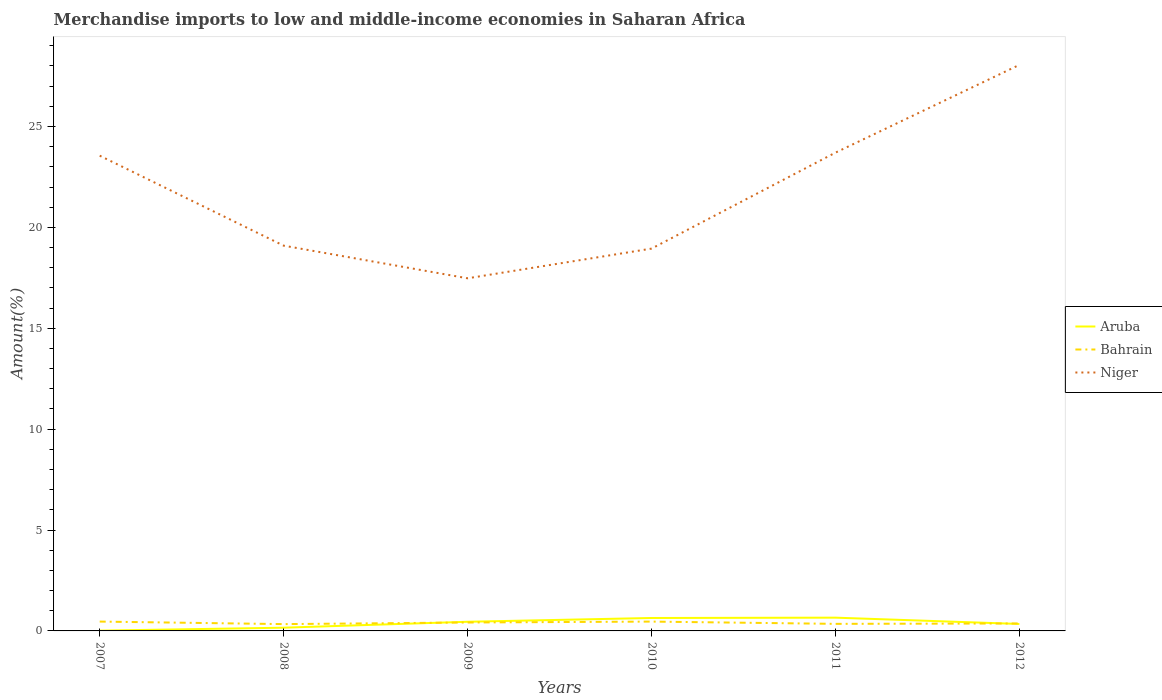Does the line corresponding to Niger intersect with the line corresponding to Bahrain?
Give a very brief answer. No. Is the number of lines equal to the number of legend labels?
Make the answer very short. Yes. Across all years, what is the maximum percentage of amount earned from merchandise imports in Aruba?
Give a very brief answer. 0.01. What is the total percentage of amount earned from merchandise imports in Niger in the graph?
Offer a terse response. -4.76. What is the difference between the highest and the second highest percentage of amount earned from merchandise imports in Niger?
Your response must be concise. 10.58. What is the difference between the highest and the lowest percentage of amount earned from merchandise imports in Aruba?
Make the answer very short. 3. How many years are there in the graph?
Keep it short and to the point. 6. What is the difference between two consecutive major ticks on the Y-axis?
Ensure brevity in your answer.  5. Does the graph contain any zero values?
Provide a short and direct response. No. Where does the legend appear in the graph?
Give a very brief answer. Center right. How are the legend labels stacked?
Your answer should be very brief. Vertical. What is the title of the graph?
Give a very brief answer. Merchandise imports to low and middle-income economies in Saharan Africa. What is the label or title of the X-axis?
Provide a succinct answer. Years. What is the label or title of the Y-axis?
Provide a succinct answer. Amount(%). What is the Amount(%) in Aruba in 2007?
Make the answer very short. 0.01. What is the Amount(%) of Bahrain in 2007?
Ensure brevity in your answer.  0.46. What is the Amount(%) in Niger in 2007?
Your response must be concise. 23.55. What is the Amount(%) of Aruba in 2008?
Ensure brevity in your answer.  0.16. What is the Amount(%) in Bahrain in 2008?
Provide a short and direct response. 0.34. What is the Amount(%) of Niger in 2008?
Keep it short and to the point. 19.09. What is the Amount(%) of Aruba in 2009?
Your response must be concise. 0.45. What is the Amount(%) in Bahrain in 2009?
Offer a terse response. 0.42. What is the Amount(%) of Niger in 2009?
Your answer should be very brief. 17.48. What is the Amount(%) in Aruba in 2010?
Your answer should be very brief. 0.64. What is the Amount(%) in Bahrain in 2010?
Your answer should be very brief. 0.46. What is the Amount(%) of Niger in 2010?
Provide a succinct answer. 18.95. What is the Amount(%) in Aruba in 2011?
Your answer should be very brief. 0.66. What is the Amount(%) of Bahrain in 2011?
Offer a very short reply. 0.35. What is the Amount(%) of Niger in 2011?
Offer a terse response. 23.7. What is the Amount(%) of Aruba in 2012?
Keep it short and to the point. 0.34. What is the Amount(%) in Bahrain in 2012?
Provide a succinct answer. 0.37. What is the Amount(%) of Niger in 2012?
Ensure brevity in your answer.  28.05. Across all years, what is the maximum Amount(%) of Aruba?
Offer a very short reply. 0.66. Across all years, what is the maximum Amount(%) in Bahrain?
Provide a succinct answer. 0.46. Across all years, what is the maximum Amount(%) of Niger?
Provide a short and direct response. 28.05. Across all years, what is the minimum Amount(%) in Aruba?
Ensure brevity in your answer.  0.01. Across all years, what is the minimum Amount(%) of Bahrain?
Your answer should be compact. 0.34. Across all years, what is the minimum Amount(%) of Niger?
Ensure brevity in your answer.  17.48. What is the total Amount(%) in Aruba in the graph?
Provide a succinct answer. 2.27. What is the total Amount(%) in Bahrain in the graph?
Keep it short and to the point. 2.4. What is the total Amount(%) in Niger in the graph?
Provide a short and direct response. 130.83. What is the difference between the Amount(%) of Aruba in 2007 and that in 2008?
Provide a succinct answer. -0.15. What is the difference between the Amount(%) in Bahrain in 2007 and that in 2008?
Provide a short and direct response. 0.13. What is the difference between the Amount(%) of Niger in 2007 and that in 2008?
Ensure brevity in your answer.  4.46. What is the difference between the Amount(%) of Aruba in 2007 and that in 2009?
Provide a succinct answer. -0.44. What is the difference between the Amount(%) in Bahrain in 2007 and that in 2009?
Offer a terse response. 0.05. What is the difference between the Amount(%) in Niger in 2007 and that in 2009?
Offer a very short reply. 6.08. What is the difference between the Amount(%) of Aruba in 2007 and that in 2010?
Provide a succinct answer. -0.63. What is the difference between the Amount(%) in Bahrain in 2007 and that in 2010?
Ensure brevity in your answer.  0. What is the difference between the Amount(%) of Niger in 2007 and that in 2010?
Offer a terse response. 4.61. What is the difference between the Amount(%) of Aruba in 2007 and that in 2011?
Make the answer very short. -0.64. What is the difference between the Amount(%) of Bahrain in 2007 and that in 2011?
Give a very brief answer. 0.11. What is the difference between the Amount(%) in Niger in 2007 and that in 2011?
Ensure brevity in your answer.  -0.15. What is the difference between the Amount(%) in Aruba in 2007 and that in 2012?
Provide a succinct answer. -0.33. What is the difference between the Amount(%) of Bahrain in 2007 and that in 2012?
Your answer should be compact. 0.09. What is the difference between the Amount(%) in Niger in 2007 and that in 2012?
Keep it short and to the point. -4.5. What is the difference between the Amount(%) of Aruba in 2008 and that in 2009?
Make the answer very short. -0.29. What is the difference between the Amount(%) of Bahrain in 2008 and that in 2009?
Your answer should be compact. -0.08. What is the difference between the Amount(%) of Niger in 2008 and that in 2009?
Ensure brevity in your answer.  1.62. What is the difference between the Amount(%) of Aruba in 2008 and that in 2010?
Offer a very short reply. -0.48. What is the difference between the Amount(%) of Bahrain in 2008 and that in 2010?
Keep it short and to the point. -0.12. What is the difference between the Amount(%) of Niger in 2008 and that in 2010?
Offer a terse response. 0.15. What is the difference between the Amount(%) in Aruba in 2008 and that in 2011?
Your answer should be compact. -0.5. What is the difference between the Amount(%) of Bahrain in 2008 and that in 2011?
Keep it short and to the point. -0.01. What is the difference between the Amount(%) in Niger in 2008 and that in 2011?
Your response must be concise. -4.61. What is the difference between the Amount(%) in Aruba in 2008 and that in 2012?
Give a very brief answer. -0.18. What is the difference between the Amount(%) in Bahrain in 2008 and that in 2012?
Ensure brevity in your answer.  -0.03. What is the difference between the Amount(%) of Niger in 2008 and that in 2012?
Your answer should be compact. -8.96. What is the difference between the Amount(%) in Aruba in 2009 and that in 2010?
Your response must be concise. -0.19. What is the difference between the Amount(%) in Bahrain in 2009 and that in 2010?
Your answer should be very brief. -0.05. What is the difference between the Amount(%) of Niger in 2009 and that in 2010?
Offer a terse response. -1.47. What is the difference between the Amount(%) in Aruba in 2009 and that in 2011?
Offer a terse response. -0.2. What is the difference between the Amount(%) of Bahrain in 2009 and that in 2011?
Provide a succinct answer. 0.07. What is the difference between the Amount(%) in Niger in 2009 and that in 2011?
Ensure brevity in your answer.  -6.23. What is the difference between the Amount(%) of Aruba in 2009 and that in 2012?
Your answer should be very brief. 0.11. What is the difference between the Amount(%) in Bahrain in 2009 and that in 2012?
Make the answer very short. 0.05. What is the difference between the Amount(%) in Niger in 2009 and that in 2012?
Provide a short and direct response. -10.58. What is the difference between the Amount(%) of Aruba in 2010 and that in 2011?
Your response must be concise. -0.02. What is the difference between the Amount(%) of Bahrain in 2010 and that in 2011?
Your answer should be very brief. 0.11. What is the difference between the Amount(%) in Niger in 2010 and that in 2011?
Your response must be concise. -4.76. What is the difference between the Amount(%) in Aruba in 2010 and that in 2012?
Give a very brief answer. 0.3. What is the difference between the Amount(%) in Bahrain in 2010 and that in 2012?
Give a very brief answer. 0.09. What is the difference between the Amount(%) in Niger in 2010 and that in 2012?
Your answer should be very brief. -9.11. What is the difference between the Amount(%) in Aruba in 2011 and that in 2012?
Provide a succinct answer. 0.31. What is the difference between the Amount(%) in Bahrain in 2011 and that in 2012?
Your response must be concise. -0.02. What is the difference between the Amount(%) in Niger in 2011 and that in 2012?
Give a very brief answer. -4.35. What is the difference between the Amount(%) in Aruba in 2007 and the Amount(%) in Bahrain in 2008?
Keep it short and to the point. -0.32. What is the difference between the Amount(%) in Aruba in 2007 and the Amount(%) in Niger in 2008?
Provide a short and direct response. -19.08. What is the difference between the Amount(%) of Bahrain in 2007 and the Amount(%) of Niger in 2008?
Provide a short and direct response. -18.63. What is the difference between the Amount(%) in Aruba in 2007 and the Amount(%) in Bahrain in 2009?
Give a very brief answer. -0.4. What is the difference between the Amount(%) of Aruba in 2007 and the Amount(%) of Niger in 2009?
Your answer should be compact. -17.46. What is the difference between the Amount(%) in Bahrain in 2007 and the Amount(%) in Niger in 2009?
Provide a succinct answer. -17.01. What is the difference between the Amount(%) in Aruba in 2007 and the Amount(%) in Bahrain in 2010?
Keep it short and to the point. -0.45. What is the difference between the Amount(%) of Aruba in 2007 and the Amount(%) of Niger in 2010?
Provide a short and direct response. -18.93. What is the difference between the Amount(%) in Bahrain in 2007 and the Amount(%) in Niger in 2010?
Your answer should be compact. -18.48. What is the difference between the Amount(%) of Aruba in 2007 and the Amount(%) of Bahrain in 2011?
Give a very brief answer. -0.34. What is the difference between the Amount(%) of Aruba in 2007 and the Amount(%) of Niger in 2011?
Give a very brief answer. -23.69. What is the difference between the Amount(%) of Bahrain in 2007 and the Amount(%) of Niger in 2011?
Your answer should be very brief. -23.24. What is the difference between the Amount(%) of Aruba in 2007 and the Amount(%) of Bahrain in 2012?
Offer a terse response. -0.36. What is the difference between the Amount(%) of Aruba in 2007 and the Amount(%) of Niger in 2012?
Make the answer very short. -28.04. What is the difference between the Amount(%) in Bahrain in 2007 and the Amount(%) in Niger in 2012?
Your answer should be very brief. -27.59. What is the difference between the Amount(%) of Aruba in 2008 and the Amount(%) of Bahrain in 2009?
Offer a very short reply. -0.26. What is the difference between the Amount(%) of Aruba in 2008 and the Amount(%) of Niger in 2009?
Your answer should be very brief. -17.32. What is the difference between the Amount(%) in Bahrain in 2008 and the Amount(%) in Niger in 2009?
Your answer should be very brief. -17.14. What is the difference between the Amount(%) of Aruba in 2008 and the Amount(%) of Bahrain in 2010?
Offer a terse response. -0.3. What is the difference between the Amount(%) of Aruba in 2008 and the Amount(%) of Niger in 2010?
Provide a succinct answer. -18.79. What is the difference between the Amount(%) in Bahrain in 2008 and the Amount(%) in Niger in 2010?
Your answer should be compact. -18.61. What is the difference between the Amount(%) of Aruba in 2008 and the Amount(%) of Bahrain in 2011?
Provide a short and direct response. -0.19. What is the difference between the Amount(%) of Aruba in 2008 and the Amount(%) of Niger in 2011?
Make the answer very short. -23.54. What is the difference between the Amount(%) of Bahrain in 2008 and the Amount(%) of Niger in 2011?
Make the answer very short. -23.37. What is the difference between the Amount(%) in Aruba in 2008 and the Amount(%) in Bahrain in 2012?
Your answer should be very brief. -0.21. What is the difference between the Amount(%) of Aruba in 2008 and the Amount(%) of Niger in 2012?
Offer a very short reply. -27.89. What is the difference between the Amount(%) in Bahrain in 2008 and the Amount(%) in Niger in 2012?
Your answer should be compact. -27.72. What is the difference between the Amount(%) of Aruba in 2009 and the Amount(%) of Bahrain in 2010?
Offer a terse response. -0.01. What is the difference between the Amount(%) of Aruba in 2009 and the Amount(%) of Niger in 2010?
Give a very brief answer. -18.49. What is the difference between the Amount(%) of Bahrain in 2009 and the Amount(%) of Niger in 2010?
Ensure brevity in your answer.  -18.53. What is the difference between the Amount(%) in Aruba in 2009 and the Amount(%) in Bahrain in 2011?
Your answer should be very brief. 0.1. What is the difference between the Amount(%) in Aruba in 2009 and the Amount(%) in Niger in 2011?
Give a very brief answer. -23.25. What is the difference between the Amount(%) of Bahrain in 2009 and the Amount(%) of Niger in 2011?
Make the answer very short. -23.29. What is the difference between the Amount(%) in Aruba in 2009 and the Amount(%) in Bahrain in 2012?
Provide a succinct answer. 0.08. What is the difference between the Amount(%) of Aruba in 2009 and the Amount(%) of Niger in 2012?
Provide a short and direct response. -27.6. What is the difference between the Amount(%) of Bahrain in 2009 and the Amount(%) of Niger in 2012?
Give a very brief answer. -27.64. What is the difference between the Amount(%) in Aruba in 2010 and the Amount(%) in Bahrain in 2011?
Ensure brevity in your answer.  0.29. What is the difference between the Amount(%) of Aruba in 2010 and the Amount(%) of Niger in 2011?
Provide a succinct answer. -23.06. What is the difference between the Amount(%) of Bahrain in 2010 and the Amount(%) of Niger in 2011?
Make the answer very short. -23.24. What is the difference between the Amount(%) in Aruba in 2010 and the Amount(%) in Bahrain in 2012?
Offer a very short reply. 0.27. What is the difference between the Amount(%) in Aruba in 2010 and the Amount(%) in Niger in 2012?
Your answer should be compact. -27.41. What is the difference between the Amount(%) in Bahrain in 2010 and the Amount(%) in Niger in 2012?
Offer a very short reply. -27.59. What is the difference between the Amount(%) in Aruba in 2011 and the Amount(%) in Bahrain in 2012?
Provide a short and direct response. 0.29. What is the difference between the Amount(%) in Aruba in 2011 and the Amount(%) in Niger in 2012?
Provide a succinct answer. -27.4. What is the difference between the Amount(%) in Bahrain in 2011 and the Amount(%) in Niger in 2012?
Your answer should be compact. -27.7. What is the average Amount(%) of Aruba per year?
Offer a terse response. 0.38. What is the average Amount(%) in Bahrain per year?
Your response must be concise. 0.4. What is the average Amount(%) of Niger per year?
Offer a very short reply. 21.8. In the year 2007, what is the difference between the Amount(%) in Aruba and Amount(%) in Bahrain?
Offer a very short reply. -0.45. In the year 2007, what is the difference between the Amount(%) in Aruba and Amount(%) in Niger?
Offer a very short reply. -23.54. In the year 2007, what is the difference between the Amount(%) of Bahrain and Amount(%) of Niger?
Ensure brevity in your answer.  -23.09. In the year 2008, what is the difference between the Amount(%) of Aruba and Amount(%) of Bahrain?
Provide a succinct answer. -0.18. In the year 2008, what is the difference between the Amount(%) in Aruba and Amount(%) in Niger?
Offer a very short reply. -18.93. In the year 2008, what is the difference between the Amount(%) of Bahrain and Amount(%) of Niger?
Give a very brief answer. -18.76. In the year 2009, what is the difference between the Amount(%) of Aruba and Amount(%) of Bahrain?
Offer a terse response. 0.04. In the year 2009, what is the difference between the Amount(%) of Aruba and Amount(%) of Niger?
Your response must be concise. -17.02. In the year 2009, what is the difference between the Amount(%) of Bahrain and Amount(%) of Niger?
Give a very brief answer. -17.06. In the year 2010, what is the difference between the Amount(%) in Aruba and Amount(%) in Bahrain?
Offer a terse response. 0.18. In the year 2010, what is the difference between the Amount(%) in Aruba and Amount(%) in Niger?
Your response must be concise. -18.31. In the year 2010, what is the difference between the Amount(%) in Bahrain and Amount(%) in Niger?
Your answer should be compact. -18.49. In the year 2011, what is the difference between the Amount(%) in Aruba and Amount(%) in Bahrain?
Ensure brevity in your answer.  0.31. In the year 2011, what is the difference between the Amount(%) of Aruba and Amount(%) of Niger?
Offer a very short reply. -23.05. In the year 2011, what is the difference between the Amount(%) of Bahrain and Amount(%) of Niger?
Offer a terse response. -23.35. In the year 2012, what is the difference between the Amount(%) of Aruba and Amount(%) of Bahrain?
Keep it short and to the point. -0.02. In the year 2012, what is the difference between the Amount(%) in Aruba and Amount(%) in Niger?
Your answer should be compact. -27.71. In the year 2012, what is the difference between the Amount(%) of Bahrain and Amount(%) of Niger?
Give a very brief answer. -27.68. What is the ratio of the Amount(%) of Aruba in 2007 to that in 2008?
Make the answer very short. 0.09. What is the ratio of the Amount(%) of Bahrain in 2007 to that in 2008?
Your answer should be compact. 1.37. What is the ratio of the Amount(%) of Niger in 2007 to that in 2008?
Ensure brevity in your answer.  1.23. What is the ratio of the Amount(%) of Aruba in 2007 to that in 2009?
Make the answer very short. 0.03. What is the ratio of the Amount(%) of Bahrain in 2007 to that in 2009?
Provide a short and direct response. 1.11. What is the ratio of the Amount(%) in Niger in 2007 to that in 2009?
Offer a terse response. 1.35. What is the ratio of the Amount(%) in Aruba in 2007 to that in 2010?
Your response must be concise. 0.02. What is the ratio of the Amount(%) of Bahrain in 2007 to that in 2010?
Your response must be concise. 1. What is the ratio of the Amount(%) of Niger in 2007 to that in 2010?
Offer a terse response. 1.24. What is the ratio of the Amount(%) of Aruba in 2007 to that in 2011?
Keep it short and to the point. 0.02. What is the ratio of the Amount(%) in Bahrain in 2007 to that in 2011?
Provide a short and direct response. 1.32. What is the ratio of the Amount(%) in Niger in 2007 to that in 2011?
Make the answer very short. 0.99. What is the ratio of the Amount(%) in Aruba in 2007 to that in 2012?
Your response must be concise. 0.04. What is the ratio of the Amount(%) of Bahrain in 2007 to that in 2012?
Make the answer very short. 1.25. What is the ratio of the Amount(%) in Niger in 2007 to that in 2012?
Give a very brief answer. 0.84. What is the ratio of the Amount(%) of Aruba in 2008 to that in 2009?
Offer a terse response. 0.35. What is the ratio of the Amount(%) in Bahrain in 2008 to that in 2009?
Give a very brief answer. 0.81. What is the ratio of the Amount(%) of Niger in 2008 to that in 2009?
Keep it short and to the point. 1.09. What is the ratio of the Amount(%) of Aruba in 2008 to that in 2010?
Your answer should be very brief. 0.25. What is the ratio of the Amount(%) in Bahrain in 2008 to that in 2010?
Offer a very short reply. 0.73. What is the ratio of the Amount(%) in Niger in 2008 to that in 2010?
Make the answer very short. 1.01. What is the ratio of the Amount(%) in Aruba in 2008 to that in 2011?
Offer a terse response. 0.24. What is the ratio of the Amount(%) in Bahrain in 2008 to that in 2011?
Ensure brevity in your answer.  0.96. What is the ratio of the Amount(%) of Niger in 2008 to that in 2011?
Keep it short and to the point. 0.81. What is the ratio of the Amount(%) in Aruba in 2008 to that in 2012?
Your response must be concise. 0.46. What is the ratio of the Amount(%) in Bahrain in 2008 to that in 2012?
Give a very brief answer. 0.91. What is the ratio of the Amount(%) of Niger in 2008 to that in 2012?
Ensure brevity in your answer.  0.68. What is the ratio of the Amount(%) of Aruba in 2009 to that in 2010?
Give a very brief answer. 0.71. What is the ratio of the Amount(%) of Bahrain in 2009 to that in 2010?
Your response must be concise. 0.9. What is the ratio of the Amount(%) of Niger in 2009 to that in 2010?
Keep it short and to the point. 0.92. What is the ratio of the Amount(%) in Aruba in 2009 to that in 2011?
Your answer should be compact. 0.69. What is the ratio of the Amount(%) in Bahrain in 2009 to that in 2011?
Provide a short and direct response. 1.19. What is the ratio of the Amount(%) of Niger in 2009 to that in 2011?
Ensure brevity in your answer.  0.74. What is the ratio of the Amount(%) of Aruba in 2009 to that in 2012?
Make the answer very short. 1.32. What is the ratio of the Amount(%) in Bahrain in 2009 to that in 2012?
Provide a succinct answer. 1.13. What is the ratio of the Amount(%) of Niger in 2009 to that in 2012?
Make the answer very short. 0.62. What is the ratio of the Amount(%) of Aruba in 2010 to that in 2011?
Ensure brevity in your answer.  0.98. What is the ratio of the Amount(%) in Bahrain in 2010 to that in 2011?
Provide a succinct answer. 1.32. What is the ratio of the Amount(%) in Niger in 2010 to that in 2011?
Provide a succinct answer. 0.8. What is the ratio of the Amount(%) in Aruba in 2010 to that in 2012?
Your answer should be compact. 1.86. What is the ratio of the Amount(%) in Bahrain in 2010 to that in 2012?
Offer a very short reply. 1.25. What is the ratio of the Amount(%) in Niger in 2010 to that in 2012?
Ensure brevity in your answer.  0.68. What is the ratio of the Amount(%) of Aruba in 2011 to that in 2012?
Your response must be concise. 1.91. What is the ratio of the Amount(%) in Bahrain in 2011 to that in 2012?
Your response must be concise. 0.95. What is the ratio of the Amount(%) in Niger in 2011 to that in 2012?
Give a very brief answer. 0.84. What is the difference between the highest and the second highest Amount(%) in Aruba?
Provide a short and direct response. 0.02. What is the difference between the highest and the second highest Amount(%) in Bahrain?
Offer a very short reply. 0. What is the difference between the highest and the second highest Amount(%) of Niger?
Give a very brief answer. 4.35. What is the difference between the highest and the lowest Amount(%) of Aruba?
Your answer should be compact. 0.64. What is the difference between the highest and the lowest Amount(%) of Bahrain?
Your answer should be compact. 0.13. What is the difference between the highest and the lowest Amount(%) in Niger?
Ensure brevity in your answer.  10.58. 